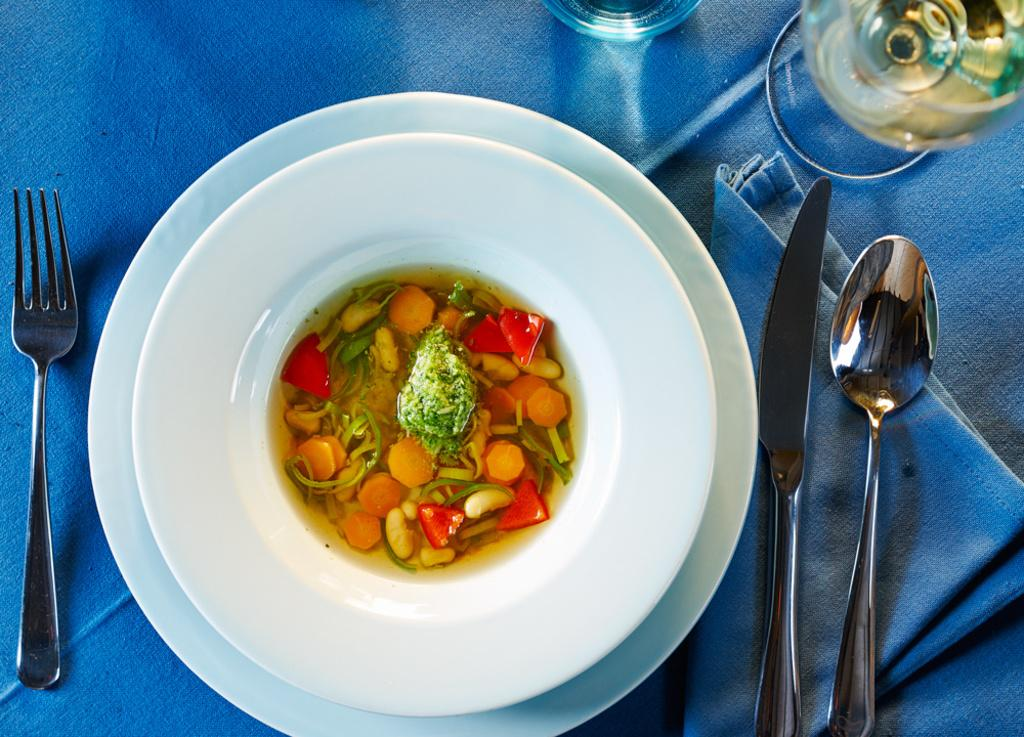What type of dishware is present in the image? There is a plate in the image. What utensils are visible in the image? There is a fork and a spoon in the image. What type of beverage container is present in the image? There is a glass in the image. What type of fabric is present in the image? There is a cloth in the image. Where are the objects located in the image? The objects are on a platform. Can you see any boats in the image? No, there are no boats present in the image. Is there a map on the platform in the image? No, there is no map present in the image. 